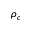Convert formula to latex. <formula><loc_0><loc_0><loc_500><loc_500>\rho _ { c }</formula> 